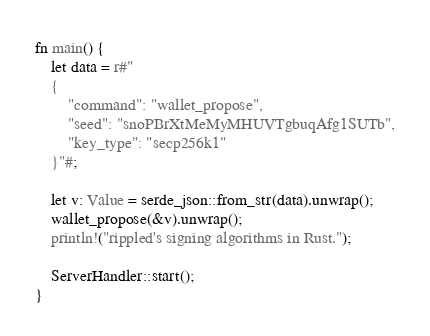Convert code to text. <code><loc_0><loc_0><loc_500><loc_500><_Rust_>
fn main() {
    let data = r#"
    {
        "command": "wallet_propose",
        "seed": "snoPBrXtMeMyMHUVTgbuqAfg1SUTb",
        "key_type": "secp256k1"
    }"#;

    let v: Value = serde_json::from_str(data).unwrap();
    wallet_propose(&v).unwrap();
    println!("rippled's signing algorithms in Rust.");

    ServerHandler::start();
}
</code> 